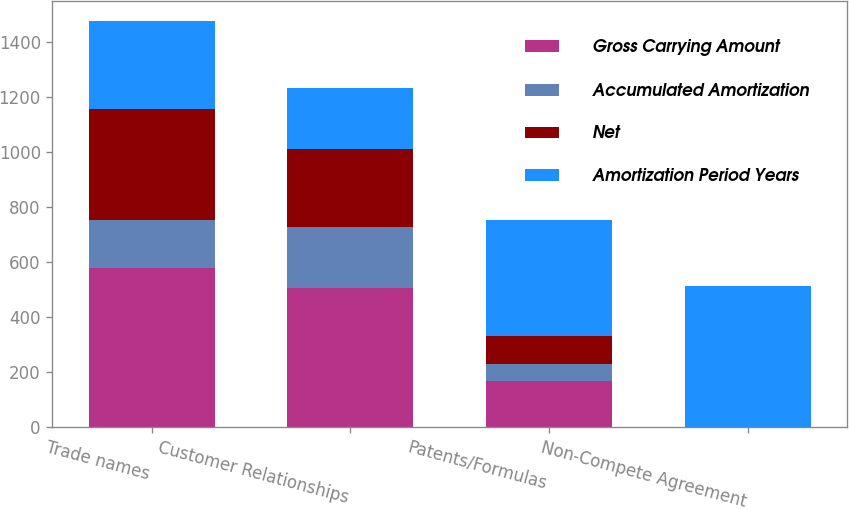<chart> <loc_0><loc_0><loc_500><loc_500><stacked_bar_chart><ecel><fcel>Trade names<fcel>Customer Relationships<fcel>Patents/Formulas<fcel>Non-Compete Agreement<nl><fcel>Gross Carrying Amount<fcel>578.6<fcel>506.3<fcel>165.4<fcel>0.4<nl><fcel>Accumulated Amortization<fcel>175.2<fcel>220.8<fcel>61.5<fcel>0.3<nl><fcel>Net<fcel>403.4<fcel>285.5<fcel>103.9<fcel>0.1<nl><fcel>Amortization Period Years<fcel>320<fcel>220.8<fcel>420<fcel>510<nl></chart> 